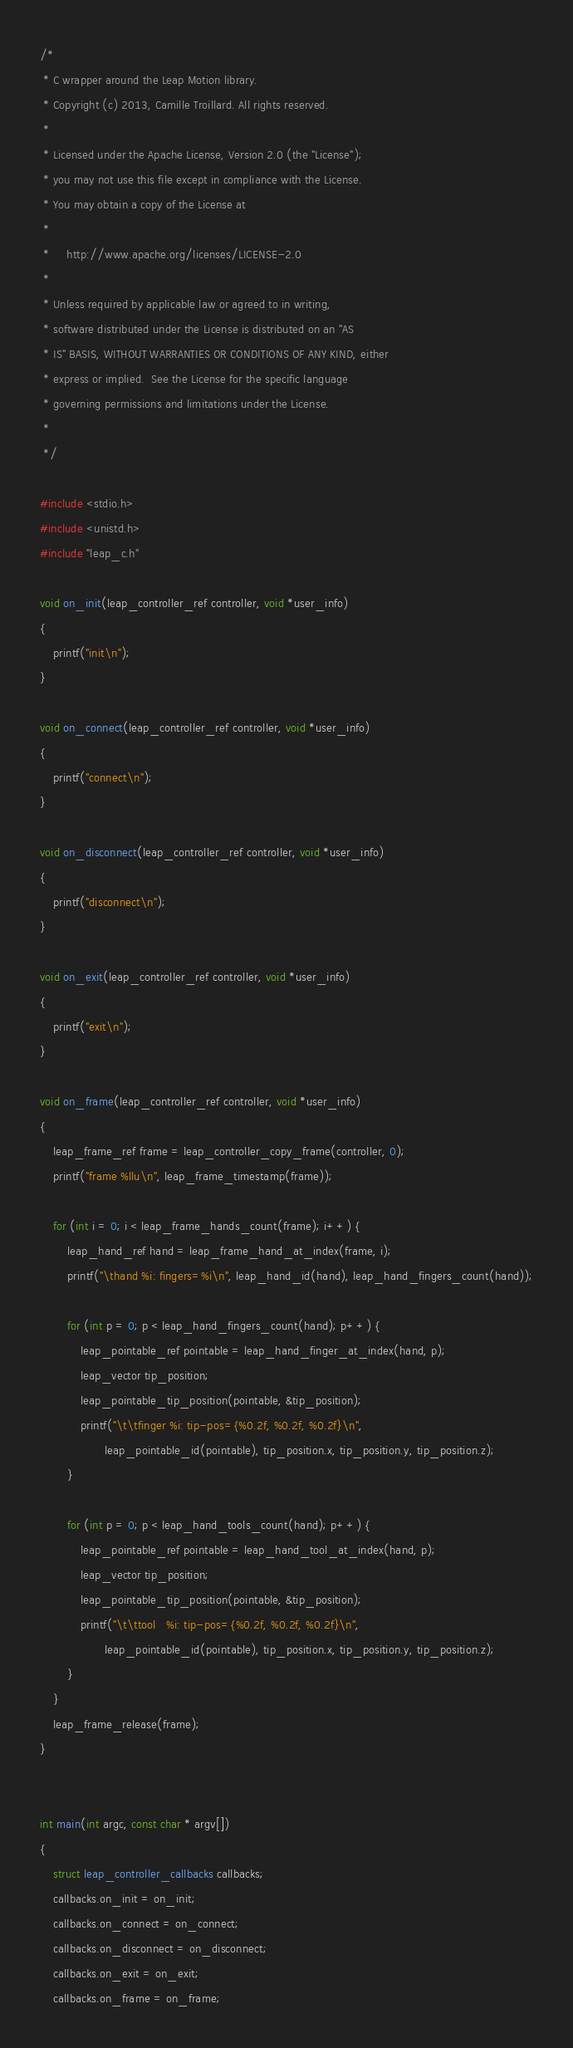Convert code to text. <code><loc_0><loc_0><loc_500><loc_500><_C_>/*
 * C wrapper around the Leap Motion library.
 * Copyright (c) 2013, Camille Troillard. All rights reserved.
 *
 * Licensed under the Apache License, Version 2.0 (the "License");
 * you may not use this file except in compliance with the License.
 * You may obtain a copy of the License at
 *
 *     http://www.apache.org/licenses/LICENSE-2.0
 *
 * Unless required by applicable law or agreed to in writing,
 * software distributed under the License is distributed on an "AS
 * IS" BASIS, WITHOUT WARRANTIES OR CONDITIONS OF ANY KIND, either
 * express or implied.  See the License for the specific language
 * governing permissions and limitations under the License.
 *
 */

#include <stdio.h>
#include <unistd.h>
#include "leap_c.h"

void on_init(leap_controller_ref controller, void *user_info)
{
    printf("init\n");
}

void on_connect(leap_controller_ref controller, void *user_info)
{
    printf("connect\n");
}

void on_disconnect(leap_controller_ref controller, void *user_info)
{
    printf("disconnect\n");
}

void on_exit(leap_controller_ref controller, void *user_info)
{
    printf("exit\n");
}

void on_frame(leap_controller_ref controller, void *user_info)
{
    leap_frame_ref frame = leap_controller_copy_frame(controller, 0);
    printf("frame %llu\n", leap_frame_timestamp(frame));

    for (int i = 0; i < leap_frame_hands_count(frame); i++) {
        leap_hand_ref hand = leap_frame_hand_at_index(frame, i);
        printf("\thand %i: fingers=%i\n", leap_hand_id(hand), leap_hand_fingers_count(hand));

        for (int p = 0; p < leap_hand_fingers_count(hand); p++) {
            leap_pointable_ref pointable = leap_hand_finger_at_index(hand, p);
            leap_vector tip_position;
            leap_pointable_tip_position(pointable, &tip_position);
            printf("\t\tfinger %i: tip-pos={%0.2f, %0.2f, %0.2f}\n",
                   leap_pointable_id(pointable), tip_position.x, tip_position.y, tip_position.z);
        }

        for (int p = 0; p < leap_hand_tools_count(hand); p++) {
            leap_pointable_ref pointable = leap_hand_tool_at_index(hand, p);
            leap_vector tip_position;
            leap_pointable_tip_position(pointable, &tip_position);
            printf("\t\ttool   %i: tip-pos={%0.2f, %0.2f, %0.2f}\n",
                   leap_pointable_id(pointable), tip_position.x, tip_position.y, tip_position.z);
        }
    }
    leap_frame_release(frame);
}


int main(int argc, const char * argv[])
{
    struct leap_controller_callbacks callbacks;
    callbacks.on_init = on_init;
    callbacks.on_connect = on_connect;
    callbacks.on_disconnect = on_disconnect;
    callbacks.on_exit = on_exit;
    callbacks.on_frame = on_frame;
</code> 